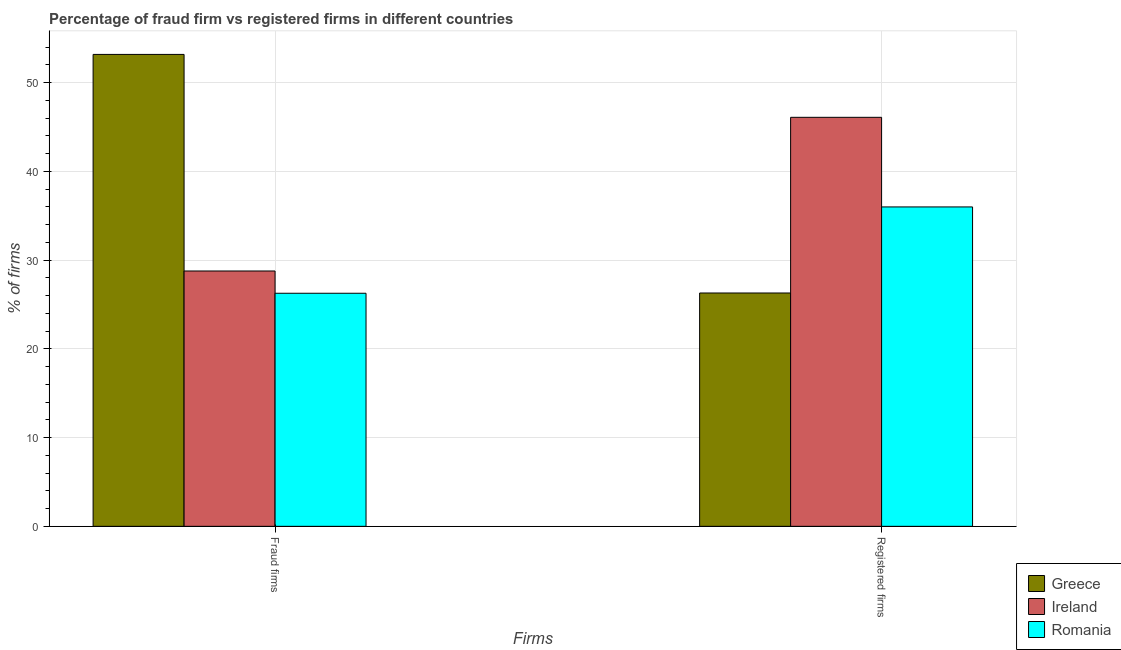How many different coloured bars are there?
Make the answer very short. 3. How many groups of bars are there?
Give a very brief answer. 2. Are the number of bars on each tick of the X-axis equal?
Your answer should be compact. Yes. How many bars are there on the 1st tick from the right?
Offer a very short reply. 3. What is the label of the 2nd group of bars from the left?
Offer a terse response. Registered firms. What is the percentage of registered firms in Greece?
Provide a succinct answer. 26.3. Across all countries, what is the maximum percentage of fraud firms?
Provide a short and direct response. 53.19. Across all countries, what is the minimum percentage of registered firms?
Offer a very short reply. 26.3. In which country was the percentage of registered firms maximum?
Provide a succinct answer. Ireland. In which country was the percentage of fraud firms minimum?
Offer a terse response. Romania. What is the total percentage of fraud firms in the graph?
Ensure brevity in your answer.  108.24. What is the difference between the percentage of fraud firms in Ireland and the percentage of registered firms in Greece?
Make the answer very short. 2.48. What is the average percentage of fraud firms per country?
Offer a terse response. 36.08. What is the difference between the percentage of registered firms and percentage of fraud firms in Romania?
Keep it short and to the point. 9.73. In how many countries, is the percentage of fraud firms greater than 4 %?
Offer a terse response. 3. What is the ratio of the percentage of fraud firms in Greece to that in Ireland?
Provide a short and direct response. 1.85. Is the percentage of registered firms in Greece less than that in Romania?
Offer a terse response. Yes. In how many countries, is the percentage of registered firms greater than the average percentage of registered firms taken over all countries?
Offer a very short reply. 1. What does the 2nd bar from the left in Registered firms represents?
Provide a succinct answer. Ireland. What does the 3rd bar from the right in Fraud firms represents?
Provide a succinct answer. Greece. How many bars are there?
Your answer should be compact. 6. How many countries are there in the graph?
Give a very brief answer. 3. Are the values on the major ticks of Y-axis written in scientific E-notation?
Your answer should be very brief. No. Does the graph contain any zero values?
Provide a succinct answer. No. Does the graph contain grids?
Offer a terse response. Yes. Where does the legend appear in the graph?
Provide a short and direct response. Bottom right. How many legend labels are there?
Offer a terse response. 3. What is the title of the graph?
Keep it short and to the point. Percentage of fraud firm vs registered firms in different countries. Does "Lebanon" appear as one of the legend labels in the graph?
Give a very brief answer. No. What is the label or title of the X-axis?
Your answer should be very brief. Firms. What is the label or title of the Y-axis?
Give a very brief answer. % of firms. What is the % of firms in Greece in Fraud firms?
Give a very brief answer. 53.19. What is the % of firms in Ireland in Fraud firms?
Provide a succinct answer. 28.78. What is the % of firms of Romania in Fraud firms?
Provide a succinct answer. 26.27. What is the % of firms in Greece in Registered firms?
Offer a very short reply. 26.3. What is the % of firms of Ireland in Registered firms?
Provide a short and direct response. 46.1. What is the % of firms of Romania in Registered firms?
Offer a very short reply. 36. Across all Firms, what is the maximum % of firms in Greece?
Give a very brief answer. 53.19. Across all Firms, what is the maximum % of firms of Ireland?
Offer a very short reply. 46.1. Across all Firms, what is the maximum % of firms of Romania?
Provide a short and direct response. 36. Across all Firms, what is the minimum % of firms of Greece?
Keep it short and to the point. 26.3. Across all Firms, what is the minimum % of firms in Ireland?
Offer a very short reply. 28.78. Across all Firms, what is the minimum % of firms of Romania?
Make the answer very short. 26.27. What is the total % of firms in Greece in the graph?
Offer a very short reply. 79.49. What is the total % of firms of Ireland in the graph?
Provide a succinct answer. 74.88. What is the total % of firms of Romania in the graph?
Keep it short and to the point. 62.27. What is the difference between the % of firms of Greece in Fraud firms and that in Registered firms?
Your answer should be compact. 26.89. What is the difference between the % of firms of Ireland in Fraud firms and that in Registered firms?
Give a very brief answer. -17.32. What is the difference between the % of firms of Romania in Fraud firms and that in Registered firms?
Your answer should be very brief. -9.73. What is the difference between the % of firms of Greece in Fraud firms and the % of firms of Ireland in Registered firms?
Your answer should be very brief. 7.09. What is the difference between the % of firms in Greece in Fraud firms and the % of firms in Romania in Registered firms?
Give a very brief answer. 17.19. What is the difference between the % of firms in Ireland in Fraud firms and the % of firms in Romania in Registered firms?
Give a very brief answer. -7.22. What is the average % of firms in Greece per Firms?
Your answer should be compact. 39.74. What is the average % of firms of Ireland per Firms?
Make the answer very short. 37.44. What is the average % of firms in Romania per Firms?
Give a very brief answer. 31.14. What is the difference between the % of firms in Greece and % of firms in Ireland in Fraud firms?
Provide a succinct answer. 24.41. What is the difference between the % of firms in Greece and % of firms in Romania in Fraud firms?
Ensure brevity in your answer.  26.92. What is the difference between the % of firms of Ireland and % of firms of Romania in Fraud firms?
Your answer should be very brief. 2.51. What is the difference between the % of firms of Greece and % of firms of Ireland in Registered firms?
Your answer should be compact. -19.8. What is the difference between the % of firms of Greece and % of firms of Romania in Registered firms?
Provide a succinct answer. -9.7. What is the difference between the % of firms in Ireland and % of firms in Romania in Registered firms?
Offer a very short reply. 10.1. What is the ratio of the % of firms of Greece in Fraud firms to that in Registered firms?
Your response must be concise. 2.02. What is the ratio of the % of firms of Ireland in Fraud firms to that in Registered firms?
Give a very brief answer. 0.62. What is the ratio of the % of firms of Romania in Fraud firms to that in Registered firms?
Your answer should be compact. 0.73. What is the difference between the highest and the second highest % of firms in Greece?
Your answer should be compact. 26.89. What is the difference between the highest and the second highest % of firms in Ireland?
Your answer should be very brief. 17.32. What is the difference between the highest and the second highest % of firms of Romania?
Your response must be concise. 9.73. What is the difference between the highest and the lowest % of firms of Greece?
Offer a terse response. 26.89. What is the difference between the highest and the lowest % of firms of Ireland?
Offer a very short reply. 17.32. What is the difference between the highest and the lowest % of firms in Romania?
Your response must be concise. 9.73. 